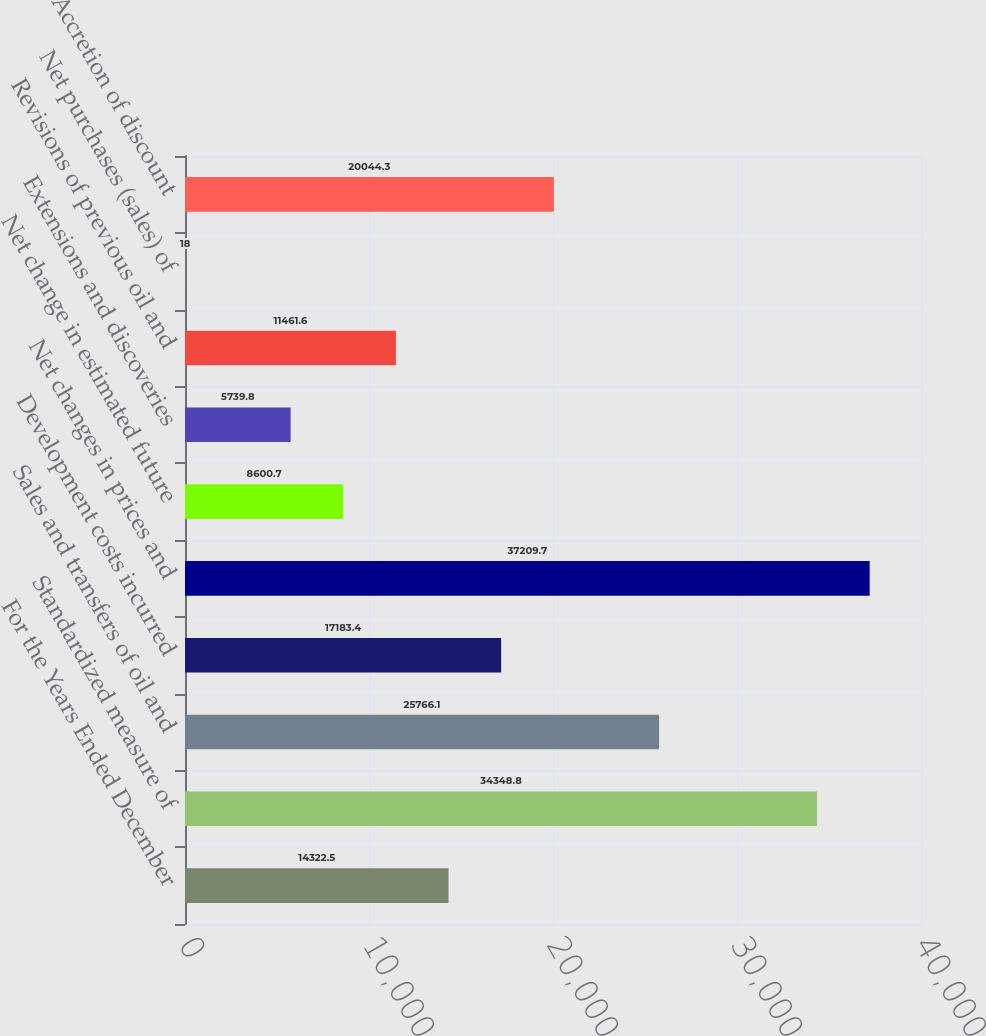<chart> <loc_0><loc_0><loc_500><loc_500><bar_chart><fcel>For the Years Ended December<fcel>Standardized measure of<fcel>Sales and transfers of oil and<fcel>Development costs incurred<fcel>Net changes in prices and<fcel>Net change in estimated future<fcel>Extensions and discoveries<fcel>Revisions of previous oil and<fcel>Net purchases (sales) of<fcel>Accretion of discount<nl><fcel>14322.5<fcel>34348.8<fcel>25766.1<fcel>17183.4<fcel>37209.7<fcel>8600.7<fcel>5739.8<fcel>11461.6<fcel>18<fcel>20044.3<nl></chart> 